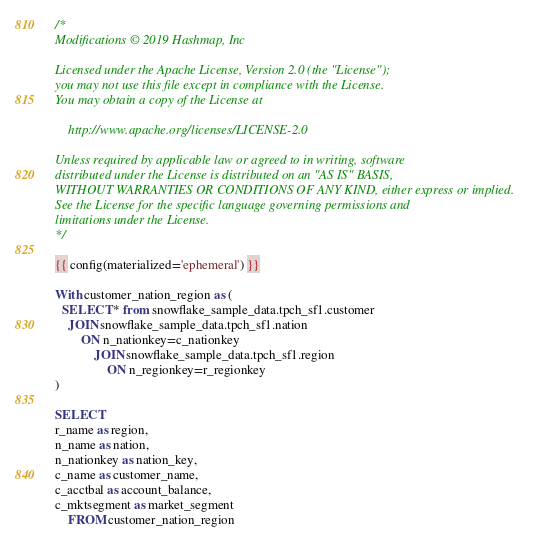Convert code to text. <code><loc_0><loc_0><loc_500><loc_500><_SQL_>/*
Modifications © 2019 Hashmap, Inc

Licensed under the Apache License, Version 2.0 (the "License");
you may not use this file except in compliance with the License.
You may obtain a copy of the License at

    http://www.apache.org/licenses/LICENSE-2.0

Unless required by applicable law or agreed to in writing, software
distributed under the License is distributed on an "AS IS" BASIS,
WITHOUT WARRANTIES OR CONDITIONS OF ANY KIND, either express or implied.
See the License for the specific language governing permissions and
limitations under the License.
*/

{{ config(materialized='ephemeral') }}

With customer_nation_region as (
  SELECT * from snowflake_sample_data.tpch_sf1.customer
    JOIN snowflake_sample_data.tpch_sf1.nation
        ON n_nationkey=c_nationkey
            JOIN snowflake_sample_data.tpch_sf1.region
                ON n_regionkey=r_regionkey
)

SELECT
r_name as region,
n_name as nation,
n_nationkey as nation_key,
c_name as customer_name,
c_acctbal as account_balance,
c_mktsegment as market_segment
    FROM customer_nation_region
</code> 